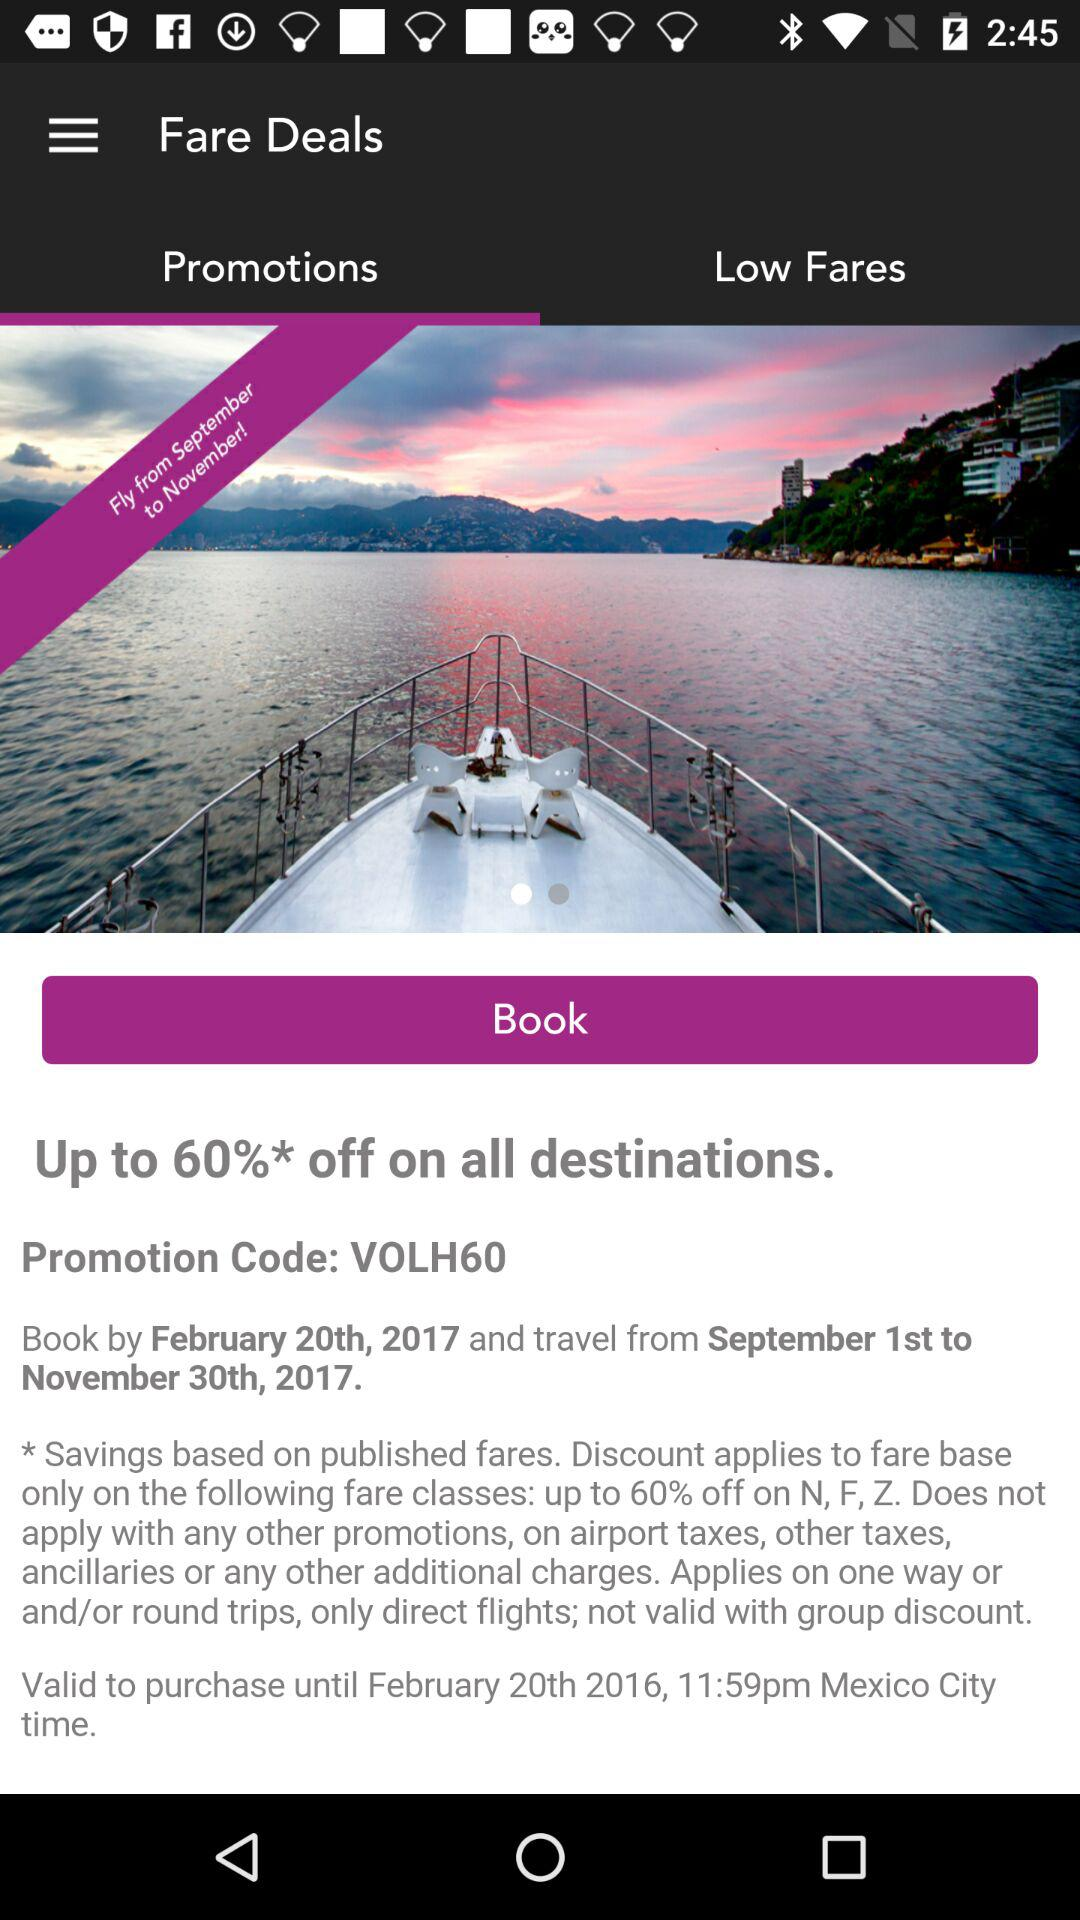Which option is selected in the "Fare Deals"? The selected option is "Promotions". 